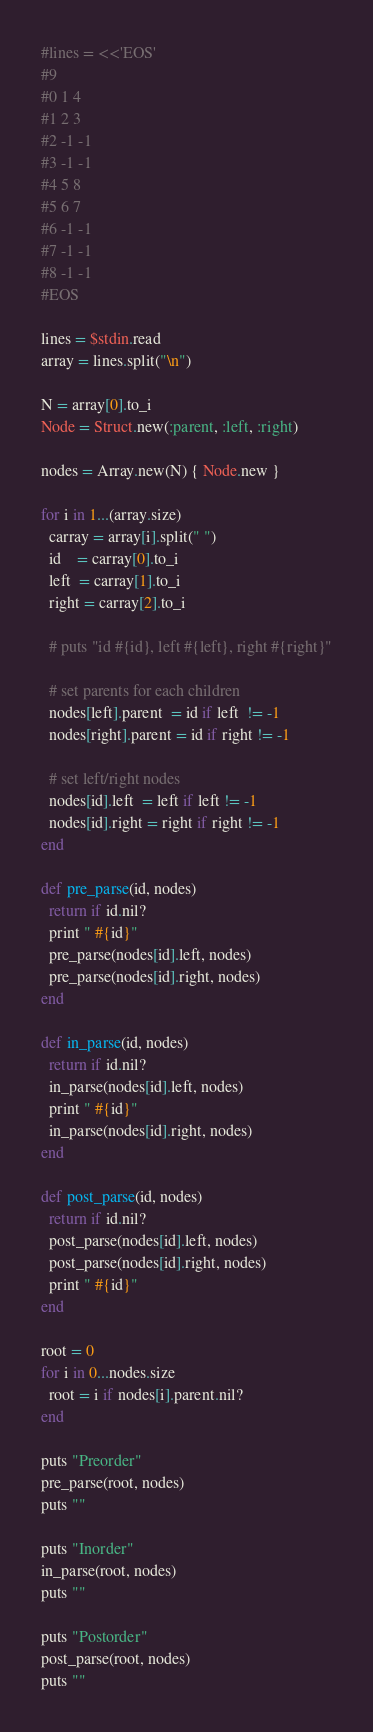Convert code to text. <code><loc_0><loc_0><loc_500><loc_500><_Ruby_>#lines = <<'EOS'
#9
#0 1 4
#1 2 3
#2 -1 -1
#3 -1 -1
#4 5 8
#5 6 7
#6 -1 -1
#7 -1 -1
#8 -1 -1
#EOS

lines = $stdin.read
array = lines.split("\n")

N = array[0].to_i
Node = Struct.new(:parent, :left, :right)

nodes = Array.new(N) { Node.new }

for i in 1...(array.size)
  carray = array[i].split(" ")
  id    = carray[0].to_i
  left  = carray[1].to_i
  right = carray[2].to_i

  # puts "id #{id}, left #{left}, right #{right}"

  # set parents for each children
  nodes[left].parent  = id if left  != -1
  nodes[right].parent = id if right != -1

  # set left/right nodes
  nodes[id].left  = left if left != -1
  nodes[id].right = right if right != -1
end

def pre_parse(id, nodes)
  return if id.nil?
  print " #{id}"
  pre_parse(nodes[id].left, nodes)
  pre_parse(nodes[id].right, nodes)
end

def in_parse(id, nodes)
  return if id.nil?
  in_parse(nodes[id].left, nodes)
  print " #{id}"
  in_parse(nodes[id].right, nodes)
end

def post_parse(id, nodes)
  return if id.nil?
  post_parse(nodes[id].left, nodes)
  post_parse(nodes[id].right, nodes)
  print " #{id}"
end

root = 0
for i in 0...nodes.size
  root = i if nodes[i].parent.nil?
end

puts "Preorder"
pre_parse(root, nodes)
puts ""

puts "Inorder"
in_parse(root, nodes)
puts ""

puts "Postorder"
post_parse(root, nodes)
puts ""</code> 